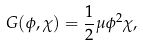<formula> <loc_0><loc_0><loc_500><loc_500>G ( \phi , \chi ) = \frac { 1 } { 2 } \mu \phi ^ { 2 } \chi ,</formula> 